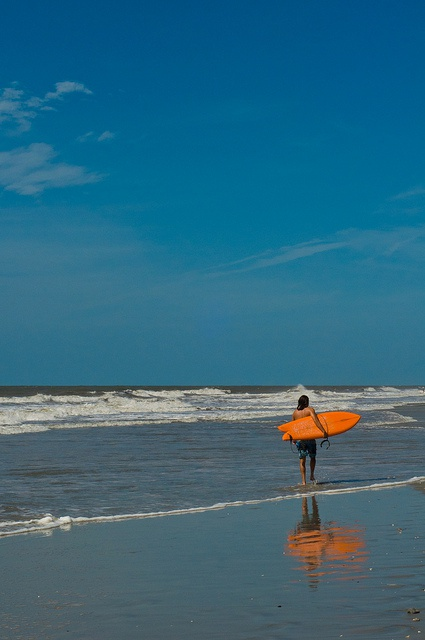Describe the objects in this image and their specific colors. I can see surfboard in blue, red, brown, maroon, and salmon tones and people in blue, black, gray, brown, and maroon tones in this image. 